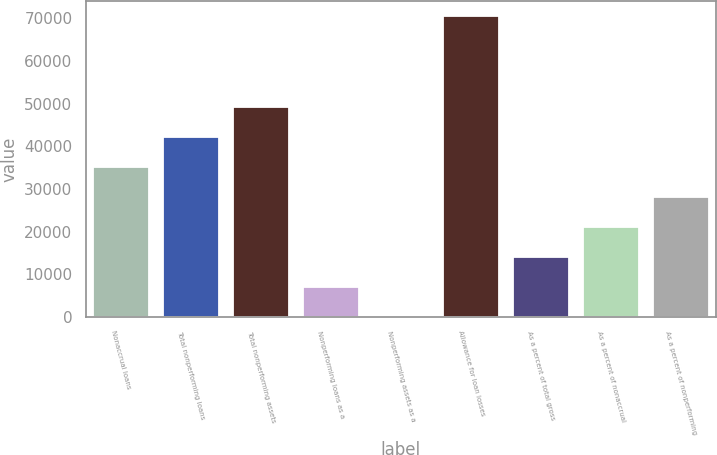<chart> <loc_0><loc_0><loc_500><loc_500><bar_chart><fcel>Nonaccrual loans<fcel>Total nonperforming loans<fcel>Total nonperforming assets<fcel>Nonperforming loans as a<fcel>Nonperforming assets as a<fcel>Allowance for loan losses<fcel>As a percent of total gross<fcel>As a percent of nonaccrual<fcel>As a percent of nonperforming<nl><fcel>35250.2<fcel>42300.2<fcel>49350.2<fcel>7050.45<fcel>0.5<fcel>70500<fcel>14100.4<fcel>21150.3<fcel>28200.3<nl></chart> 